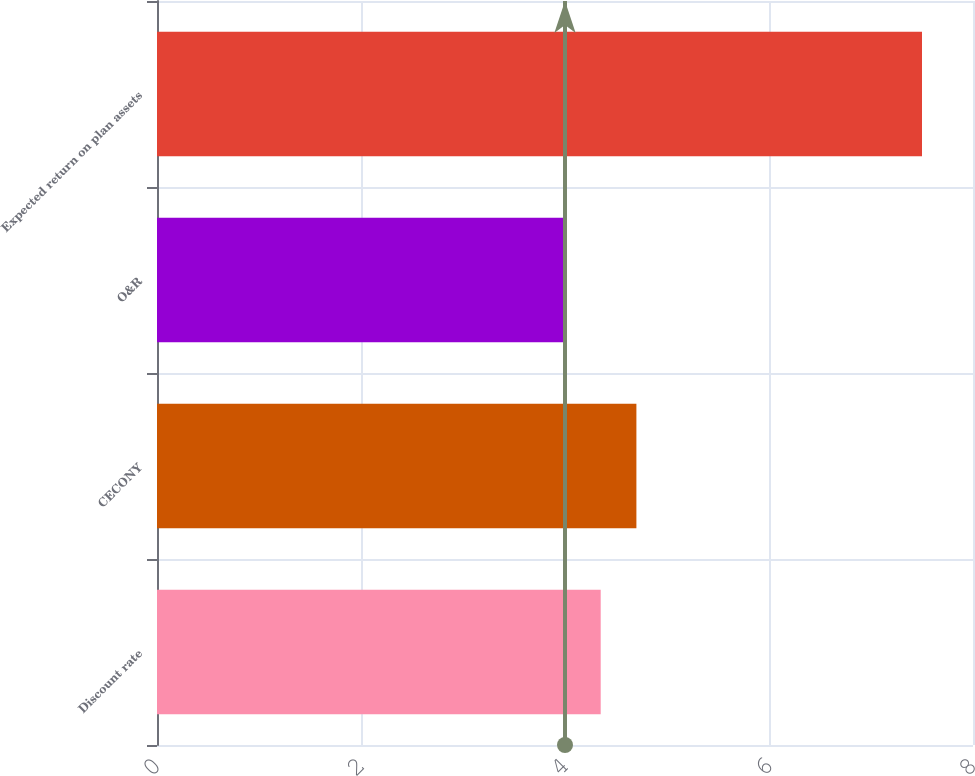<chart> <loc_0><loc_0><loc_500><loc_500><bar_chart><fcel>Discount rate<fcel>CECONY<fcel>O&R<fcel>Expected return on plan assets<nl><fcel>4.35<fcel>4.7<fcel>4<fcel>7.5<nl></chart> 